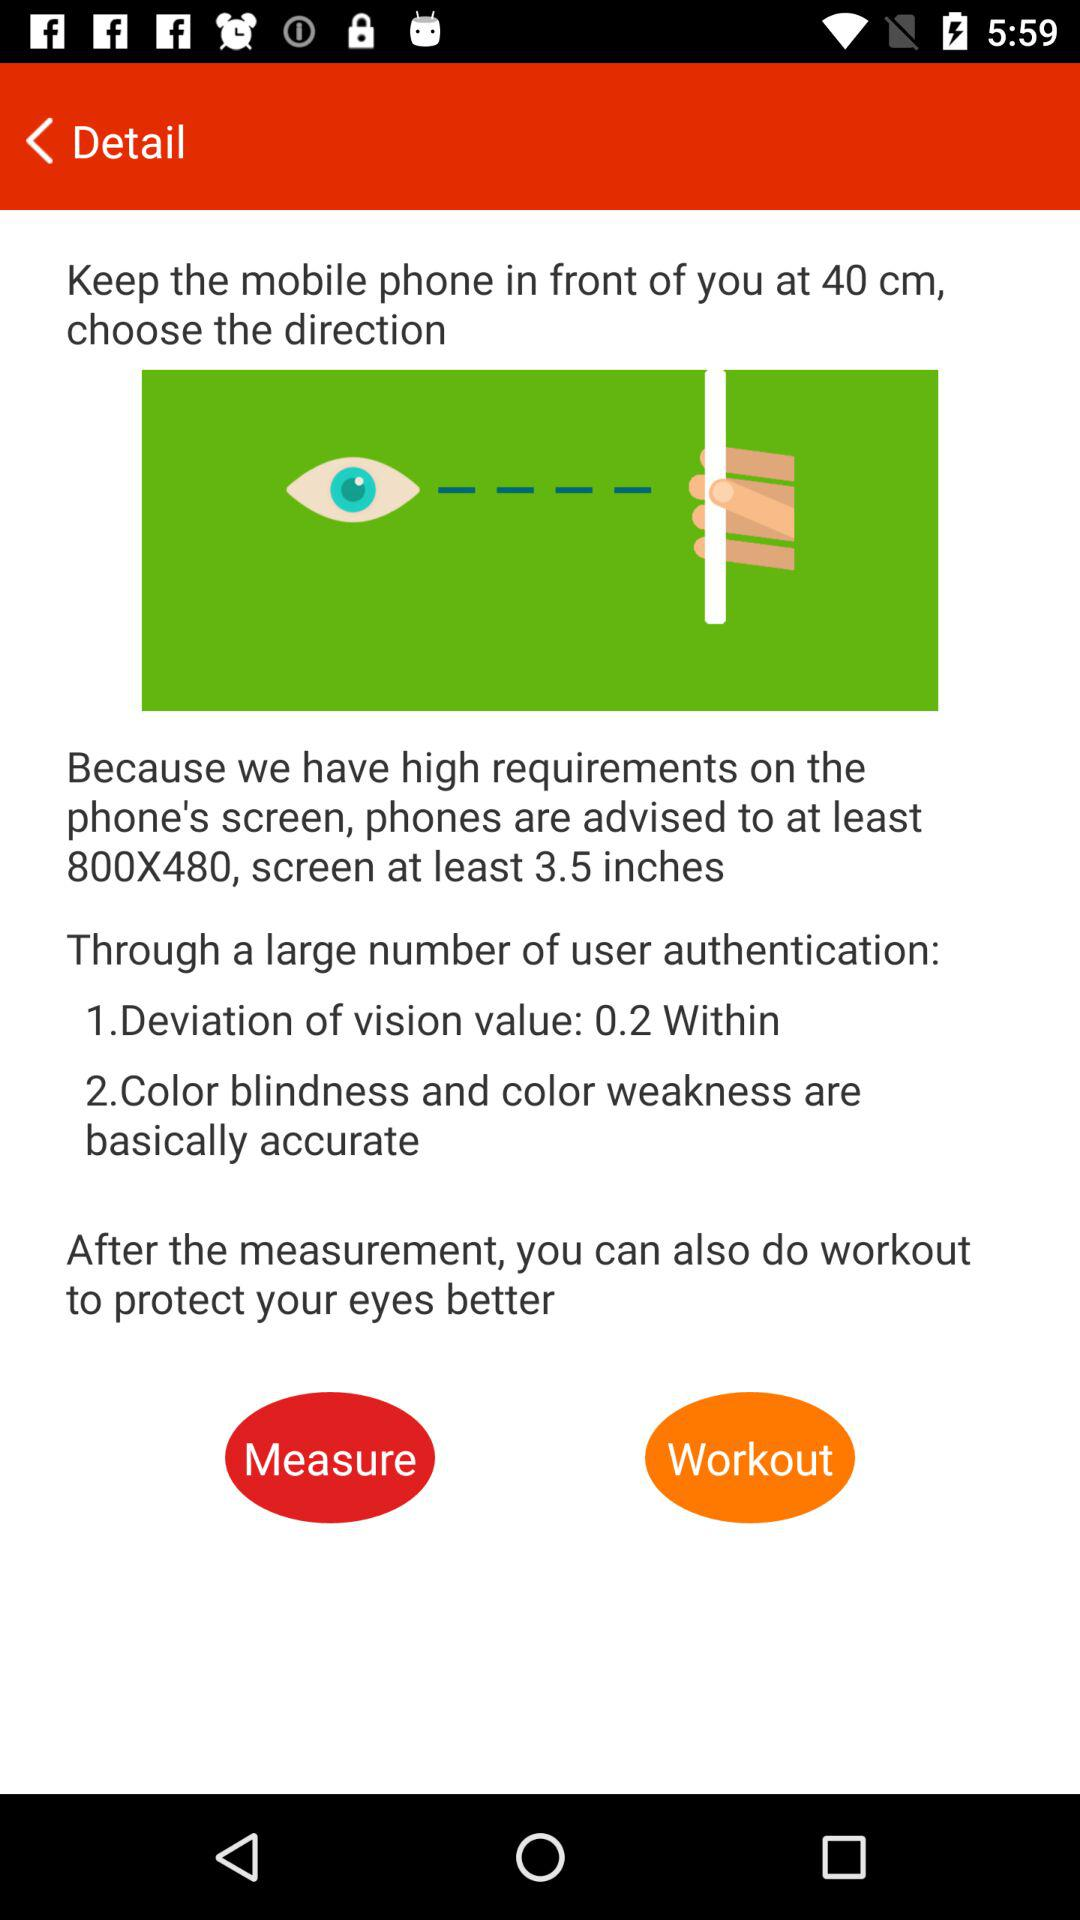What is the minimum resolution of the phone?
Answer the question using a single word or phrase. 800x480 